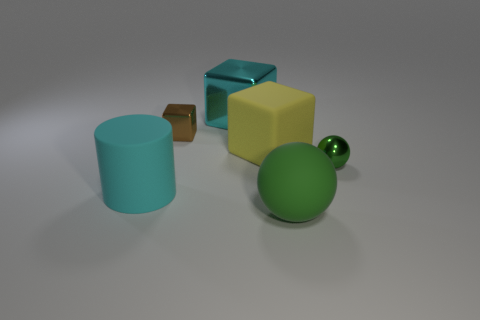Is there a small green sphere?
Your answer should be compact. Yes. There is a big thing in front of the cyan thing in front of the large yellow matte cube; how many green spheres are behind it?
Provide a succinct answer. 1. Does the large cyan metal object have the same shape as the big matte object behind the big cyan cylinder?
Ensure brevity in your answer.  Yes. Is the number of large cyan shiny blocks greater than the number of green objects?
Provide a succinct answer. No. Does the cyan object on the right side of the rubber cylinder have the same shape as the cyan matte thing?
Offer a very short reply. No. Are there more big metallic objects that are on the right side of the big green ball than tiny things?
Keep it short and to the point. No. There is a small thing that is right of the big rubber thing that is right of the yellow rubber cube; what is its color?
Offer a terse response. Green. What number of big blocks are there?
Provide a short and direct response. 2. How many objects are behind the matte cylinder and on the right side of the brown cube?
Your answer should be compact. 3. Are there any other things that have the same shape as the cyan rubber object?
Provide a short and direct response. No. 